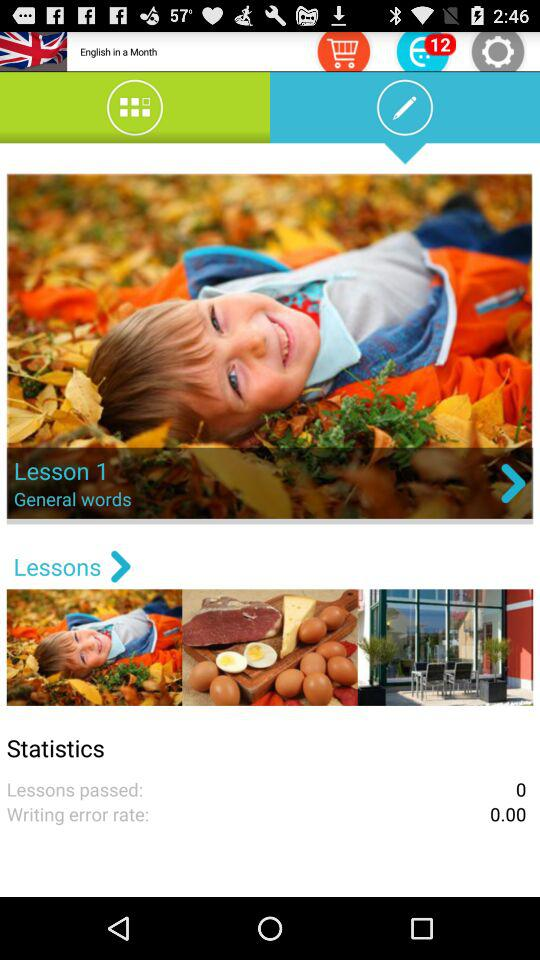Is there any item in the cart?
When the provided information is insufficient, respond with <no answer>. <no answer> 